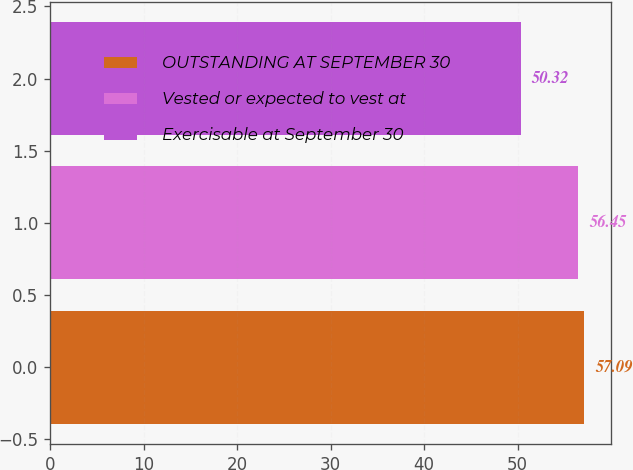Convert chart. <chart><loc_0><loc_0><loc_500><loc_500><bar_chart><fcel>OUTSTANDING AT SEPTEMBER 30<fcel>Vested or expected to vest at<fcel>Exercisable at September 30<nl><fcel>57.09<fcel>56.45<fcel>50.32<nl></chart> 